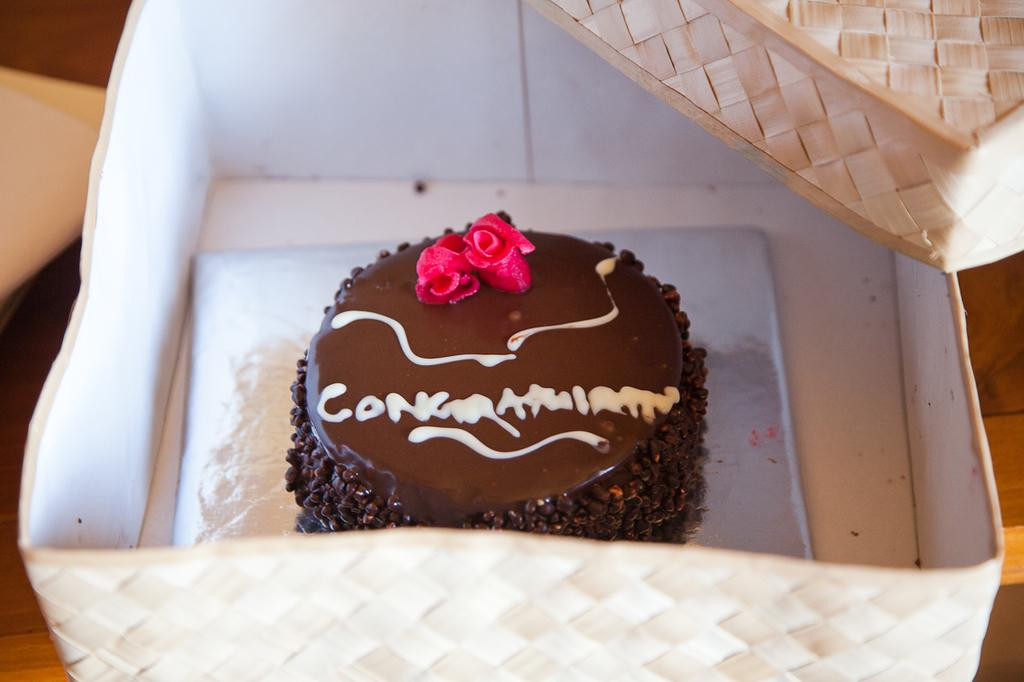What is the main subject of the image? There is a cake in the image. How is the cake being stored or transported? The cake is in a box. Where is the box with the cake located? The box is on a table. What additional information can be gathered from the cake? There is text written on the cake. What type of punishment is being administered to the wall in the image? There is no wall or punishment present in the image; it features a cake in a box on a table. Can you tell me how many scissors are visible in the image? There are no scissors present in the image. 